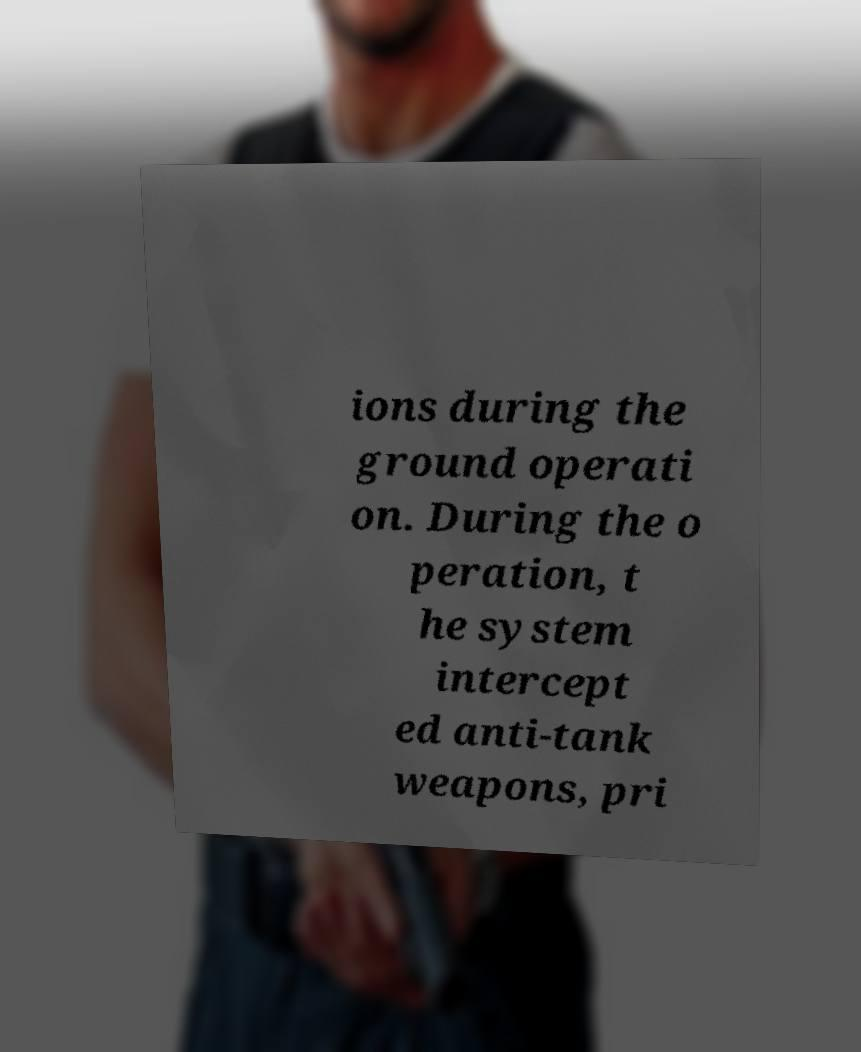Please read and relay the text visible in this image. What does it say? ions during the ground operati on. During the o peration, t he system intercept ed anti-tank weapons, pri 